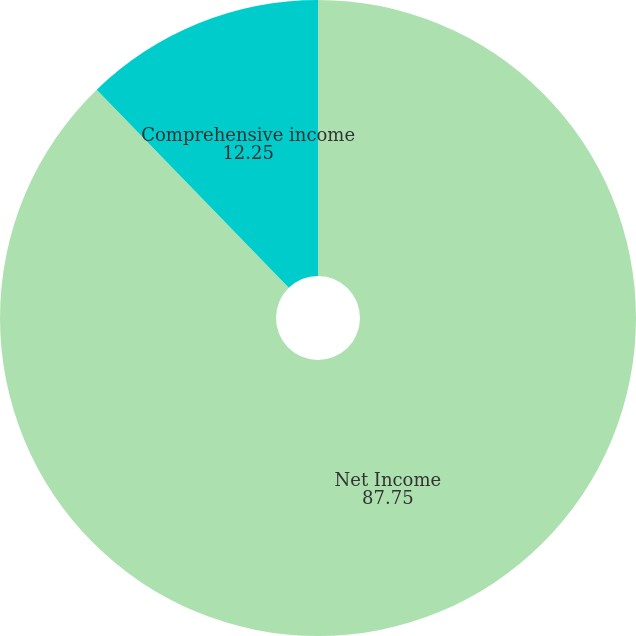Convert chart to OTSL. <chart><loc_0><loc_0><loc_500><loc_500><pie_chart><fcel>Net Income<fcel>Comprehensive income<nl><fcel>87.75%<fcel>12.25%<nl></chart> 